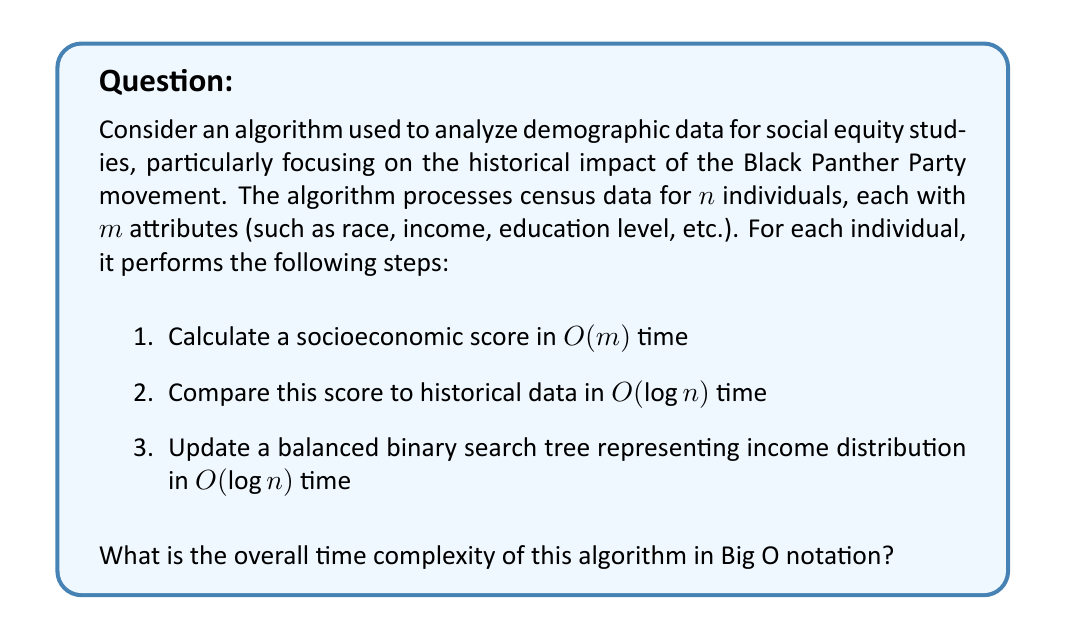Could you help me with this problem? To determine the overall time complexity, we need to analyze each step of the algorithm:

1. Calculating the socioeconomic score:
   - This step is performed for each individual and takes $O(m)$ time.
   - For $n$ individuals, this step contributes $O(nm)$ to the total complexity.

2. Comparing the score to historical data:
   - This step uses a logarithmic search, taking $O(\log n)$ time for each individual.
   - For $n$ individuals, this step contributes $O(n \log n)$ to the total complexity.

3. Updating the balanced binary search tree:
   - Updating a balanced BST takes $O(\log n)$ time for each insertion.
   - For $n$ individuals, this step contributes $O(n \log n)$ to the total complexity.

The total time complexity is the sum of these three components:

$$T(n, m) = O(nm) + O(n \log n) + O(n \log n)$$

Simplifying this expression:

$$T(n, m) = O(nm + 2n \log n) = O(nm + n \log n)$$

In Big O notation, we keep the dominant terms. The dominance between $nm$ and $n \log n$ depends on the relationship between $m$ and $\log n$. Since we don't have specific information about this relationship, we keep both terms.

Therefore, the overall time complexity of the algorithm is $O(nm + n \log n)$.
Answer: $O(nm + n \log n)$ 